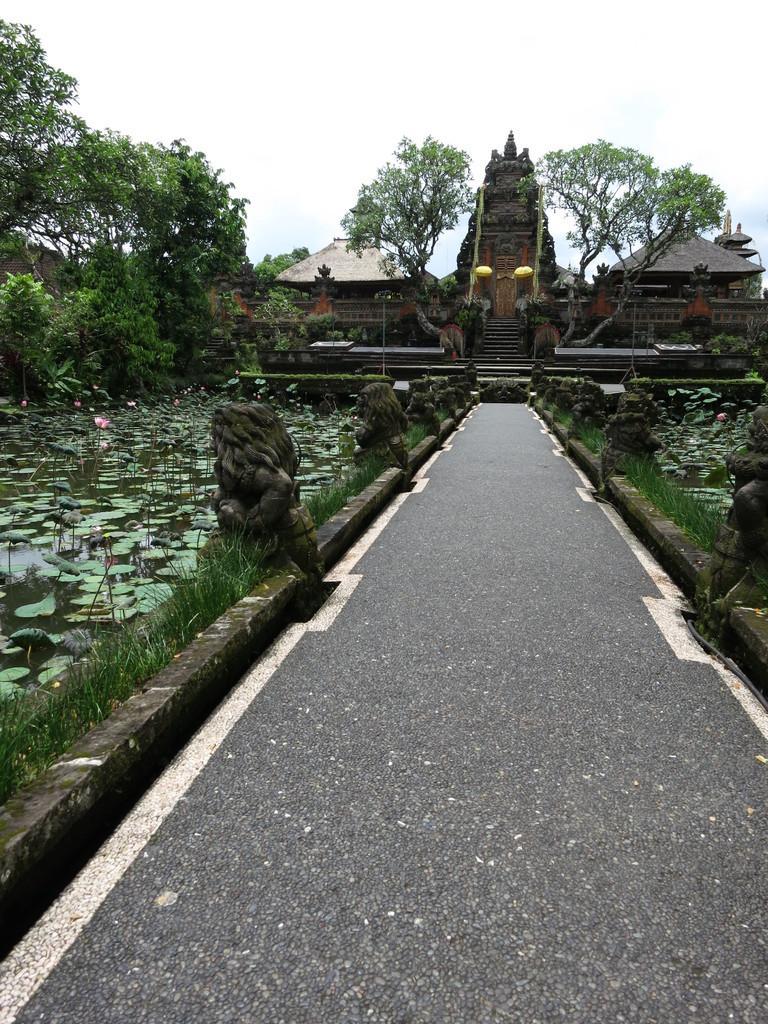Describe this image in one or two sentences. In this picture I can see the road in the middle, there are statues and plants on either side of this road. On the left side there is water and there are trees, in the background they are looking like monuments. At the top there is the sky. 